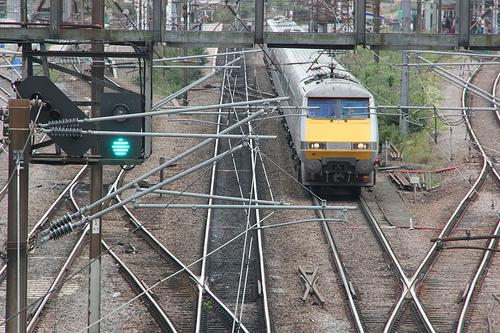Question: who is driving the train?
Choices:
A. The man.
B. Conductor.
C. The intern.
D. The old man.
Answer with the letter. Answer: B Question: what color are the train tracks?
Choices:
A. Black.
B. Brown.
C. Grey.
D. White.
Answer with the letter. Answer: C Question: what color is the front of the train?
Choices:
A. Blue.
B. Grey.
C. Yellow.
D. Black.
Answer with the letter. Answer: C Question: what color is the signal light?
Choices:
A. Yellow.
B. Red.
C. Green.
D. Orange.
Answer with the letter. Answer: C Question: what is the train conductor doing?
Choices:
A. Driving a train.
B. Checking the track.
C. Greeting passengers.
D. Looking at a map.
Answer with the letter. Answer: A 